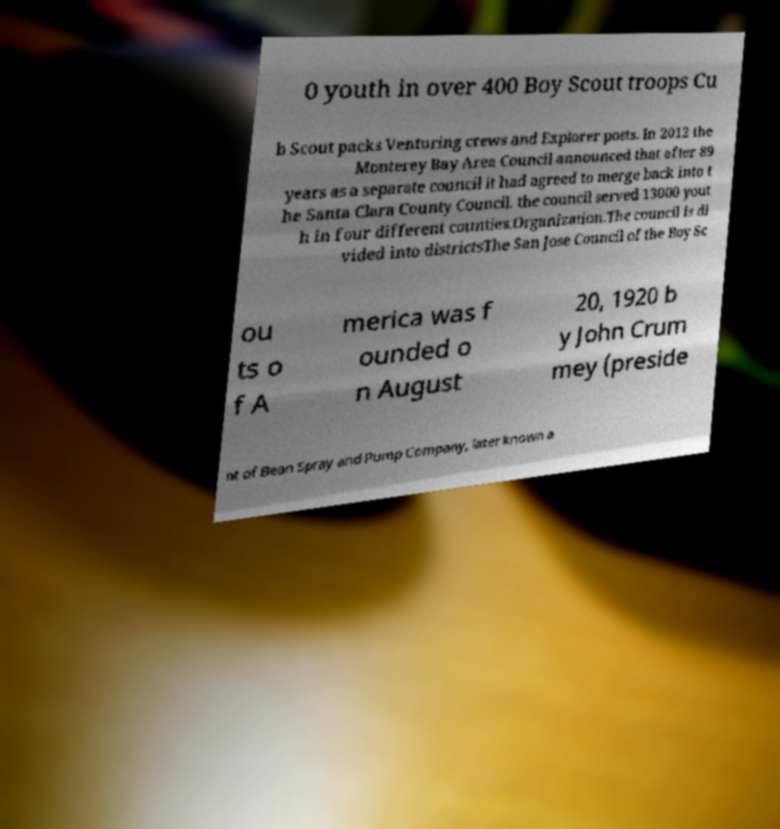Please read and relay the text visible in this image. What does it say? 0 youth in over 400 Boy Scout troops Cu b Scout packs Venturing crews and Explorer posts. In 2012 the Monterey Bay Area Council announced that after 89 years as a separate council it had agreed to merge back into t he Santa Clara County Council. the council served 13000 yout h in four different counties.Organization.The council is di vided into districtsThe San Jose Council of the Boy Sc ou ts o f A merica was f ounded o n August 20, 1920 b y John Crum mey (preside nt of Bean Spray and Pump Company, later known a 